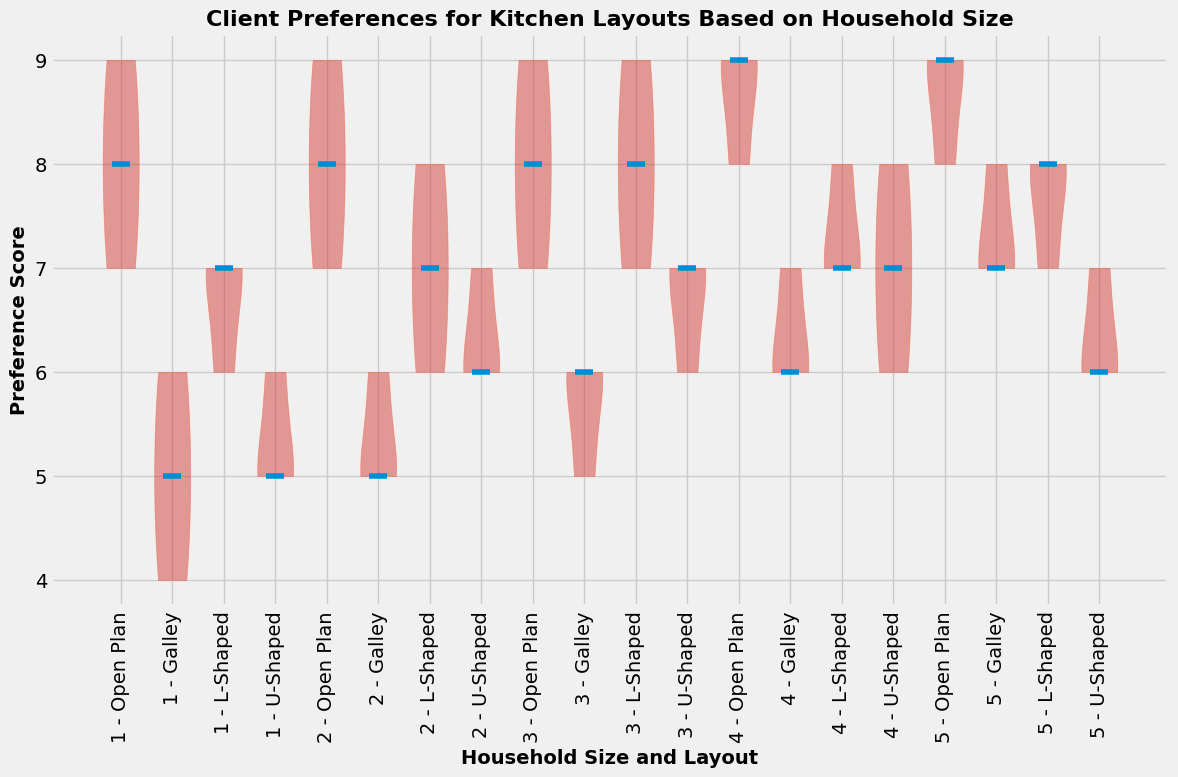Which household size has the highest median preference score for the Open Plan layout? By examining the figure, identify the violin plot segment marked for each household size and layout. The median line for the Open Plan layout for each household size (1 to 5) needs to be located to compare which one is the highest.
Answer: Household size 5 Which layout for household size 3 has the lowest median preference score? Look at the violin plot segments corresponding to household size 3. Examine the median lines for all the layouts (Open Plan, Galley, L-Shaped, U-Shaped), and identify which one has the lowest point.
Answer: Galley Is there any household size where the median preference score for L-Shaped layout is higher than the Open Plan layout? For each household size (1 to 5), compare the median lines of the L-Shaped and Open Plan layouts. Check if the median line for L-Shaped is above that of the Open Plan in any case.
Answer: No Do the preference scores show a wider range (greater variability) for household size 2 or household size 5 for the U-Shaped layout? Identify the distribution shape of the U-Shaped layout for both household sizes 2 and 5. The wider the spread of the distribution in the violin plot, the greater the variability.
Answer: Household size 5 What is the general preference score range for the Galley layout in household size 4? Observe the distribution of the Galley layout for household size 4. The range is depicted by the spread from the bottom to the top of the violin plot segment.
Answer: 6 to 7 Comparing household sizes 1 and 4, which one has a higher median preference score for the U-Shaped layout? Locate the median lines in the violin plot segments marked for household sizes 1 and 4 under the U-Shaped layout, and then compare them to see which one is higher.
Answer: Household size 4 For which layout does household size 1 show the least variation in preference scores? Examine the width and spread of the violin plots for household size 1 across all layouts. The narrowest plot will indicate the least variation.
Answer: U-Shaped Is there a layout for household size 2 where the preference score median is equal to that of household size 3? For each layout (Open Plan, Galley, L-Shaped, U-Shaped), compare the median lines between household sizes 2 and 3 to identify any equal median scores.
Answer: Yes, L-Shaped Does the Open Plan layout have a higher median preference score in household size 5 than in household size 2? Compare the Open Plan median lines between household size 5 and household size 2. If the line for household size 5 is higher, it indicates a higher preference score.
Answer: Yes 